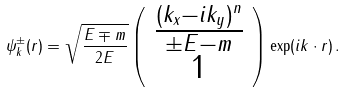<formula> <loc_0><loc_0><loc_500><loc_500>\psi _ { k } ^ { \pm } ( r ) = \sqrt { \frac { E \mp m } { 2 E } } \left ( \begin{array} { c } \frac { ( k _ { x } - i k _ { y } ) ^ { n } } { \pm E - m } \\ 1 \end{array} \right ) \exp ( i k \cdot r ) \, .</formula> 